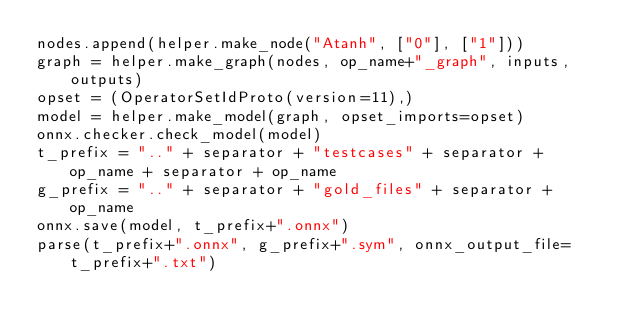<code> <loc_0><loc_0><loc_500><loc_500><_Python_>nodes.append(helper.make_node("Atanh", ["0"], ["1"]))
graph = helper.make_graph(nodes, op_name+"_graph", inputs, outputs)
opset = (OperatorSetIdProto(version=11),)
model = helper.make_model(graph, opset_imports=opset)
onnx.checker.check_model(model)
t_prefix = ".." + separator + "testcases" + separator + op_name + separator + op_name
g_prefix = ".." + separator + "gold_files" + separator + op_name
onnx.save(model, t_prefix+".onnx")
parse(t_prefix+".onnx", g_prefix+".sym", onnx_output_file=t_prefix+".txt")
</code> 